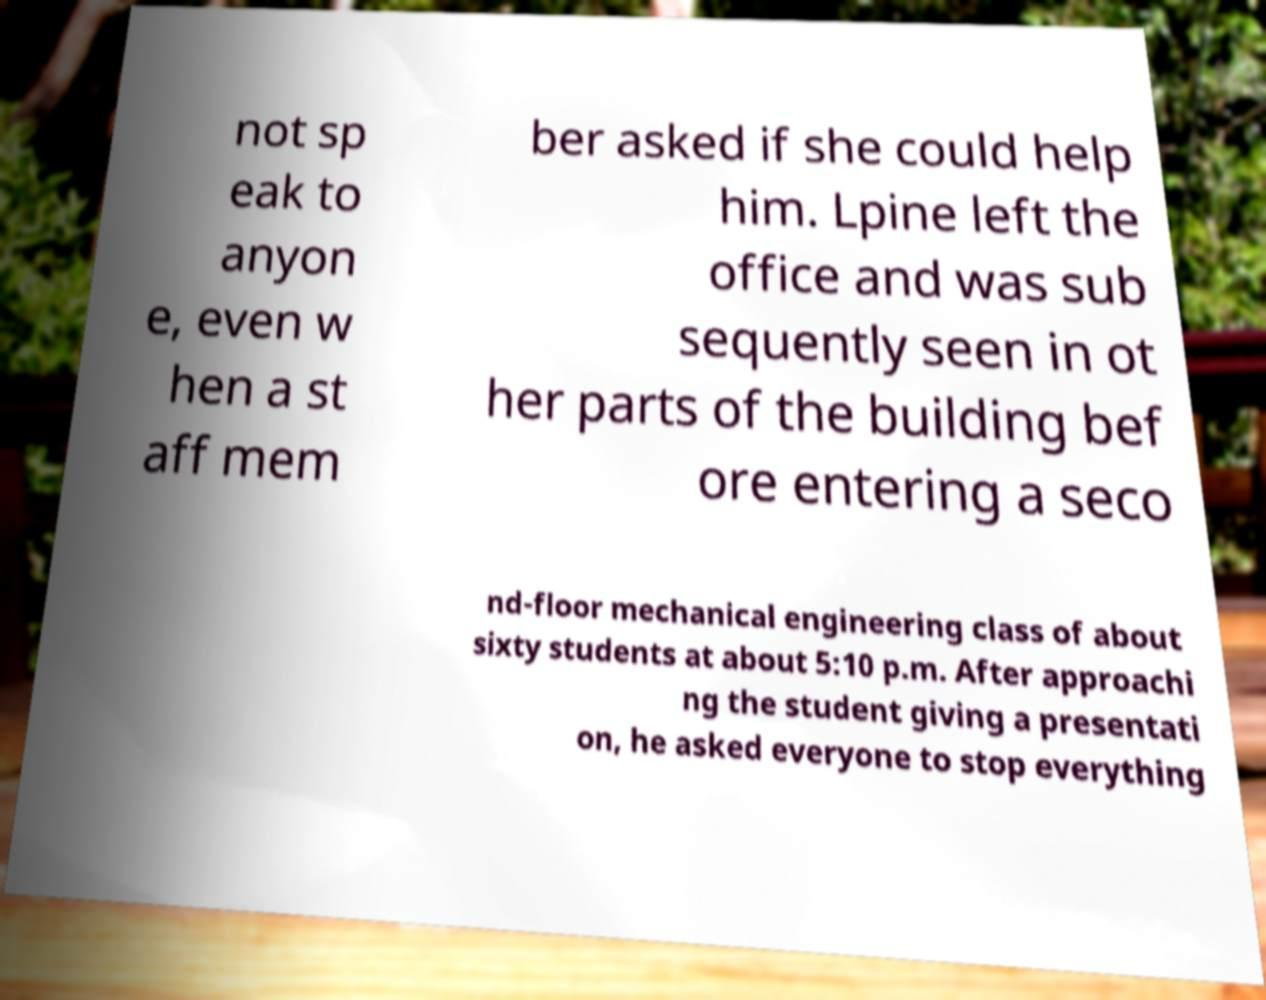Could you extract and type out the text from this image? not sp eak to anyon e, even w hen a st aff mem ber asked if she could help him. Lpine left the office and was sub sequently seen in ot her parts of the building bef ore entering a seco nd-floor mechanical engineering class of about sixty students at about 5:10 p.m. After approachi ng the student giving a presentati on, he asked everyone to stop everything 